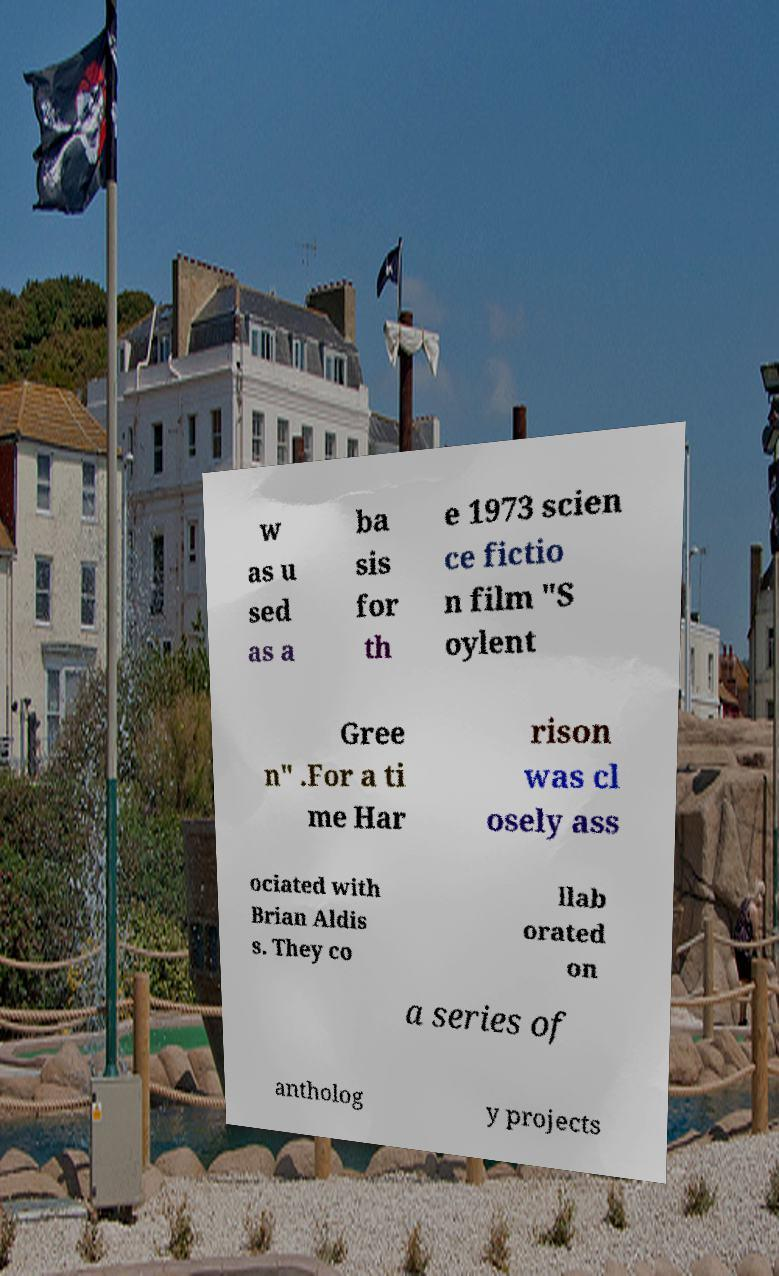Please read and relay the text visible in this image. What does it say? w as u sed as a ba sis for th e 1973 scien ce fictio n film "S oylent Gree n" .For a ti me Har rison was cl osely ass ociated with Brian Aldis s. They co llab orated on a series of antholog y projects 